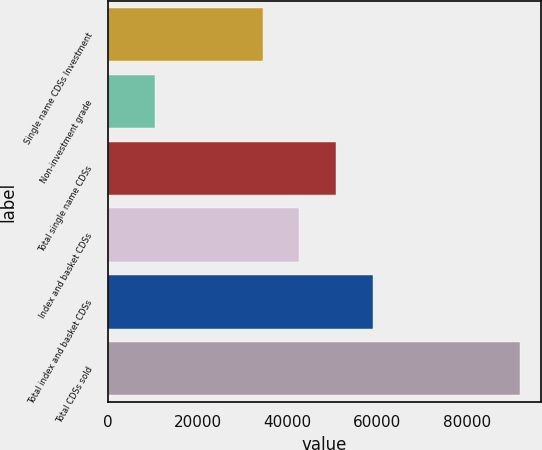Convert chart to OTSL. <chart><loc_0><loc_0><loc_500><loc_500><bar_chart><fcel>Single name CDSs Investment<fcel>Non-investment grade<fcel>Total single name CDSs<fcel>Index and basket CDSs<fcel>Total index and basket CDSs<fcel>Total CDSs sold<nl><fcel>34529<fcel>10436<fcel>50798.6<fcel>42663.8<fcel>58933.4<fcel>91784<nl></chart> 